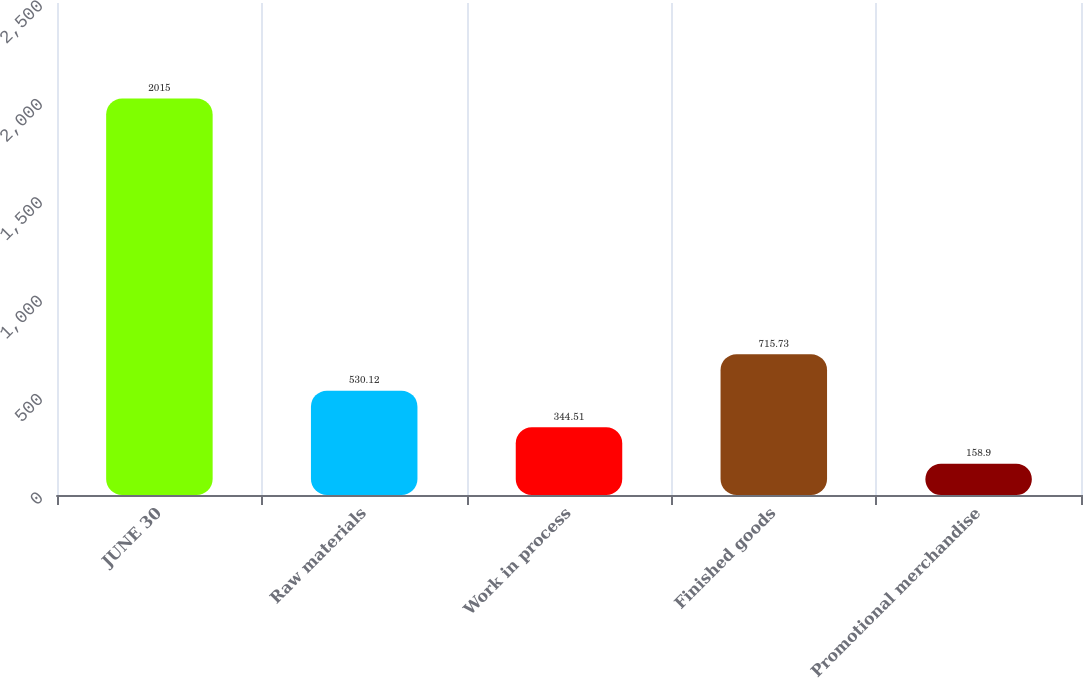Convert chart. <chart><loc_0><loc_0><loc_500><loc_500><bar_chart><fcel>JUNE 30<fcel>Raw materials<fcel>Work in process<fcel>Finished goods<fcel>Promotional merchandise<nl><fcel>2015<fcel>530.12<fcel>344.51<fcel>715.73<fcel>158.9<nl></chart> 